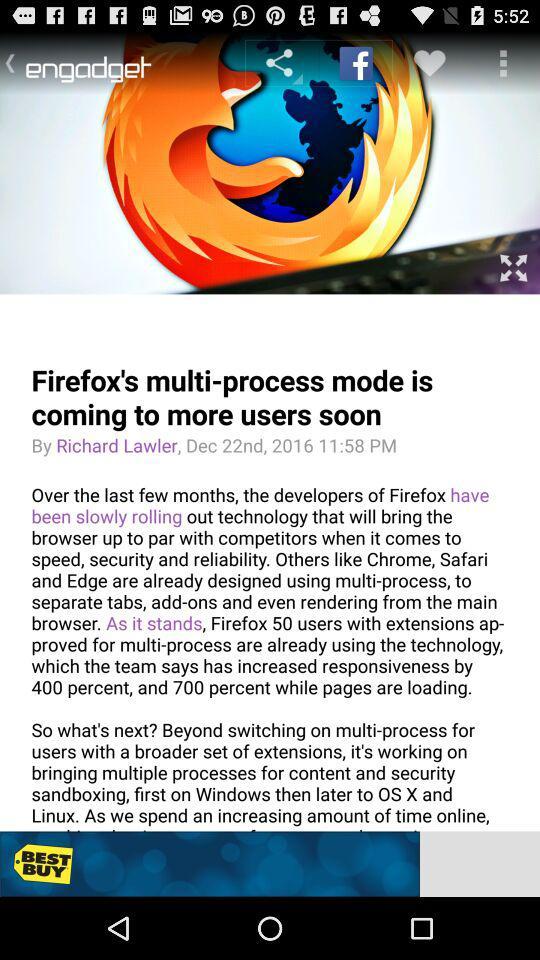Who is the author of this article?
When the provided information is insufficient, respond with <no answer>. <no answer> 